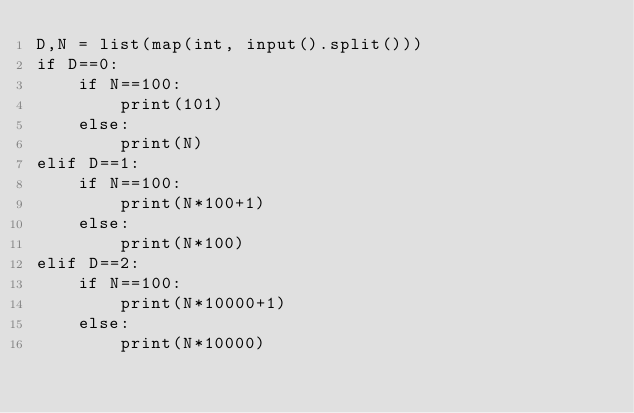<code> <loc_0><loc_0><loc_500><loc_500><_Python_>D,N = list(map(int, input().split()))
if D==0:
    if N==100:
        print(101)
    else:
        print(N)
elif D==1:
    if N==100:
        print(N*100+1)
    else:
        print(N*100)
elif D==2:
    if N==100:
        print(N*10000+1)
    else:
        print(N*10000)
</code> 